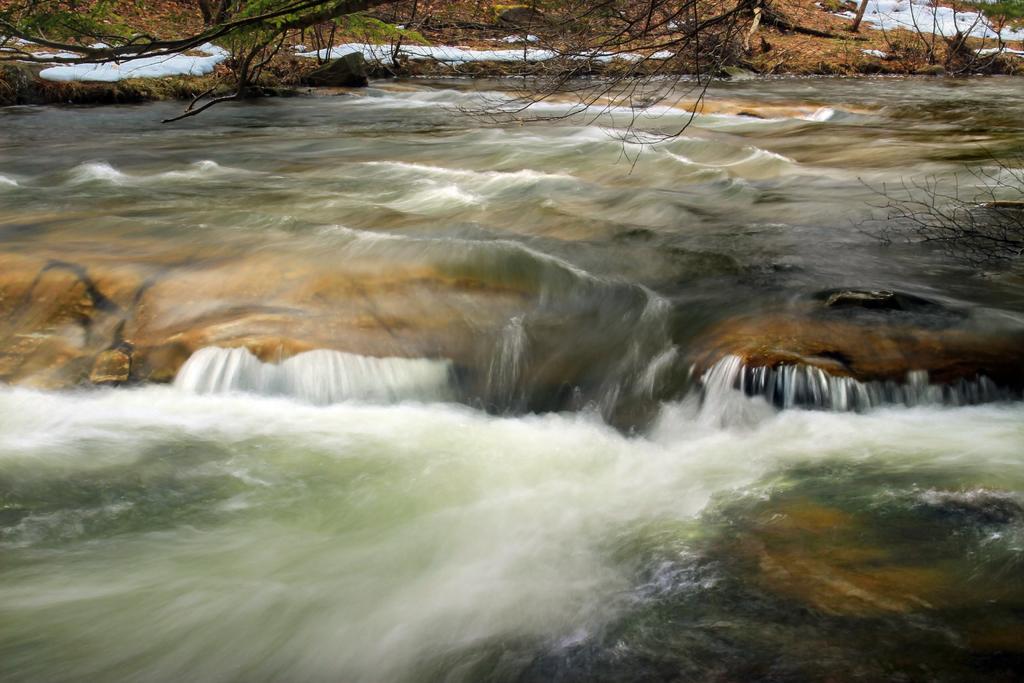Please provide a concise description of this image. In this picture we can see the water and in the background we can see trees and snow on the ground. 